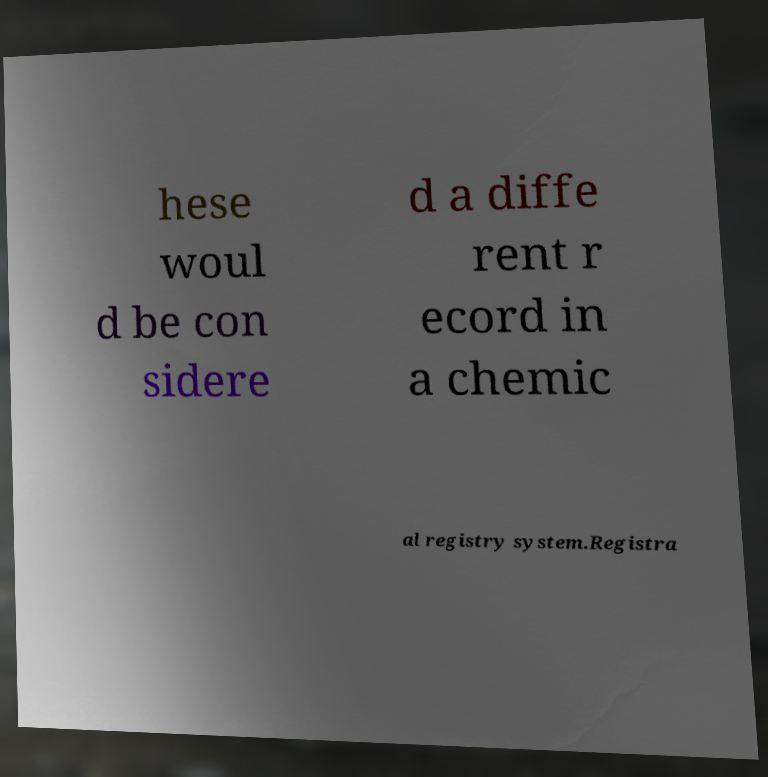For documentation purposes, I need the text within this image transcribed. Could you provide that? hese woul d be con sidere d a diffe rent r ecord in a chemic al registry system.Registra 